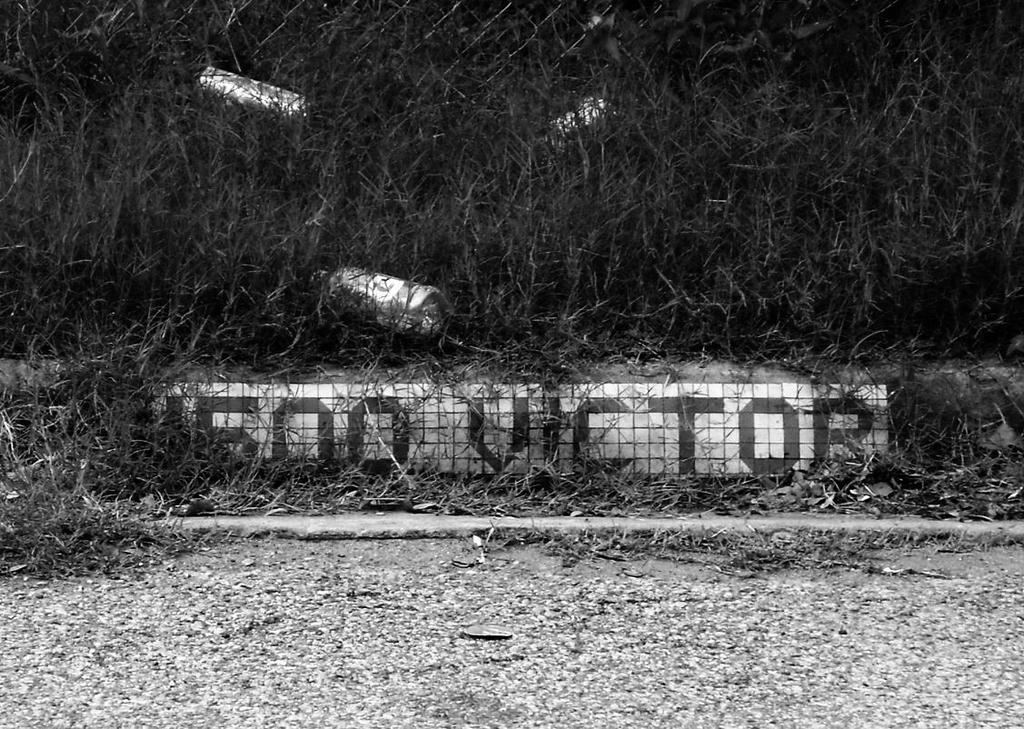What is the color scheme of the image? The image is black and white. What can be seen at the bottom of the image? There is a surface at the bottom of the image. What type of vegetation is present at the top of the image? There is grass at the top of the image. What type of grain is visible in the image? There is no grain present in the image; it features a black and white surface and grass. Can you provide an example of a colorful image for comparison? The provided image is black and white, so it cannot be used as an example for comparison with a colorful image. 